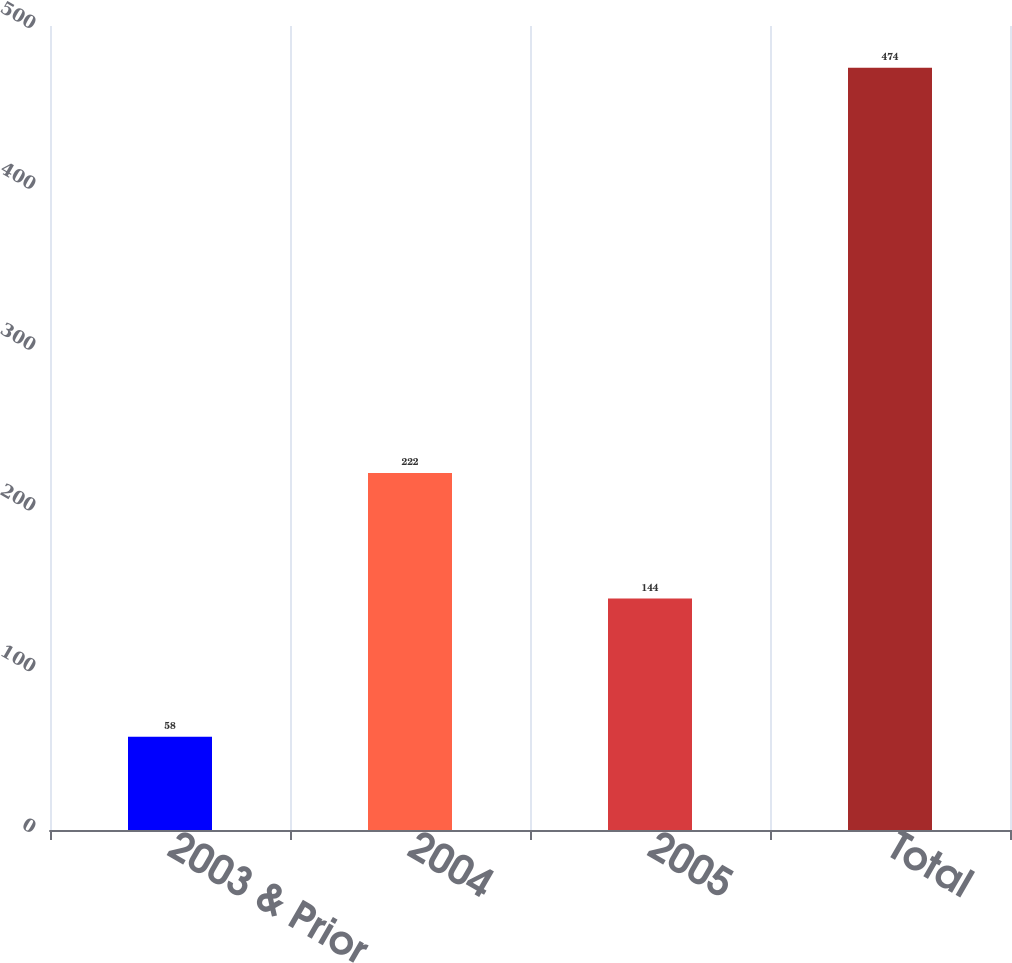Convert chart. <chart><loc_0><loc_0><loc_500><loc_500><bar_chart><fcel>2003 & Prior<fcel>2004<fcel>2005<fcel>Total<nl><fcel>58<fcel>222<fcel>144<fcel>474<nl></chart> 